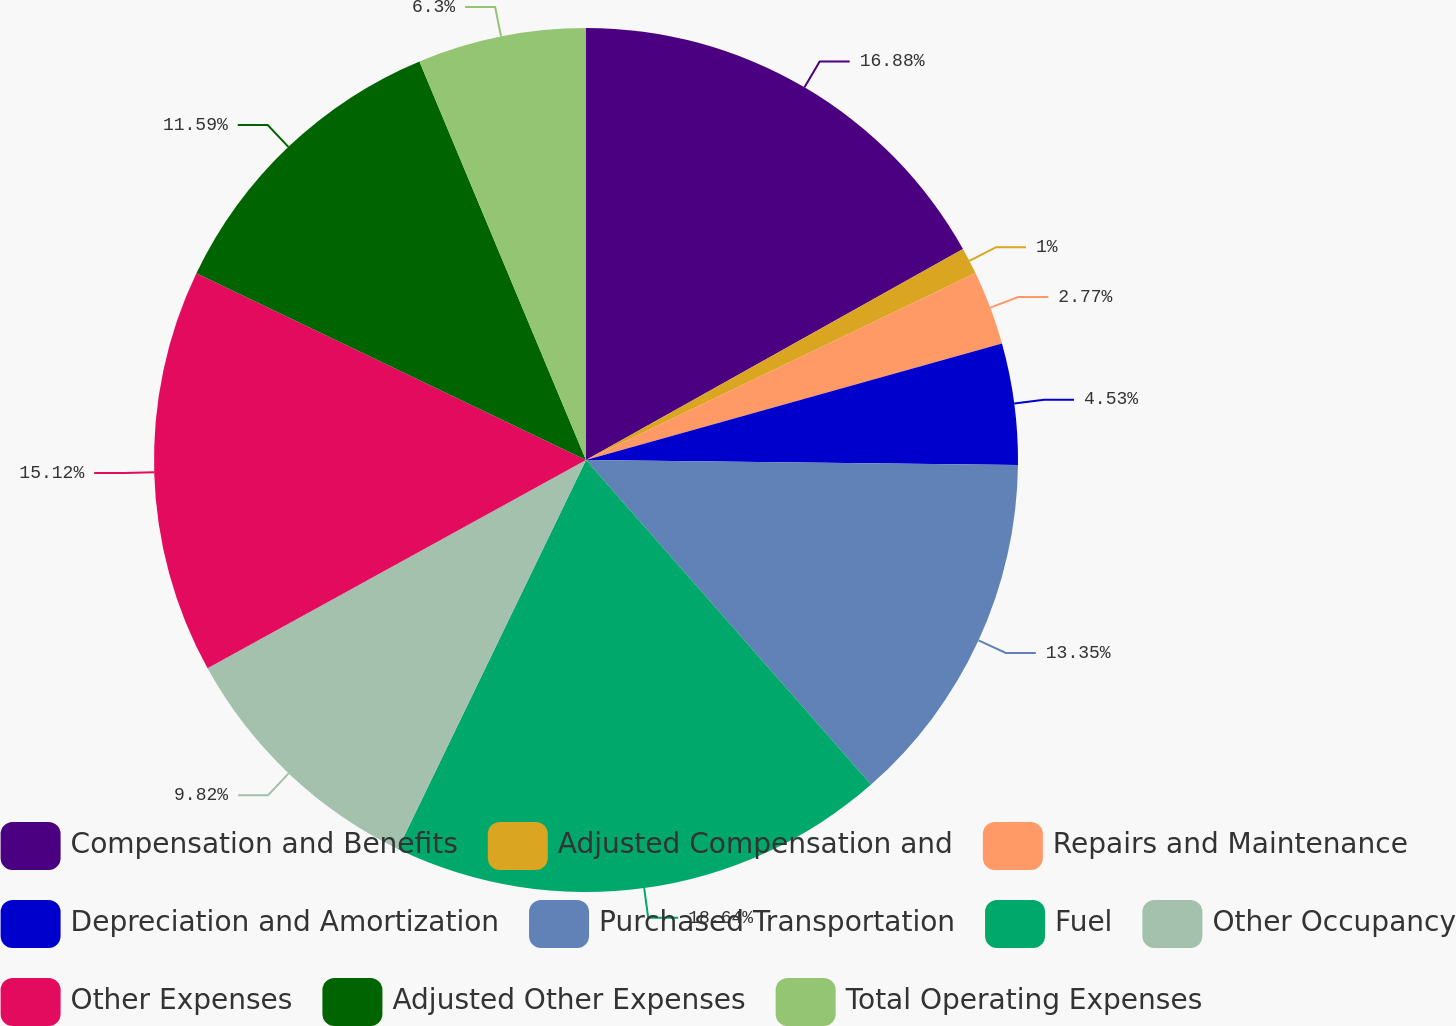Convert chart. <chart><loc_0><loc_0><loc_500><loc_500><pie_chart><fcel>Compensation and Benefits<fcel>Adjusted Compensation and<fcel>Repairs and Maintenance<fcel>Depreciation and Amortization<fcel>Purchased Transportation<fcel>Fuel<fcel>Other Occupancy<fcel>Other Expenses<fcel>Adjusted Other Expenses<fcel>Total Operating Expenses<nl><fcel>16.88%<fcel>1.0%<fcel>2.77%<fcel>4.53%<fcel>13.35%<fcel>18.64%<fcel>9.82%<fcel>15.12%<fcel>11.59%<fcel>6.3%<nl></chart> 